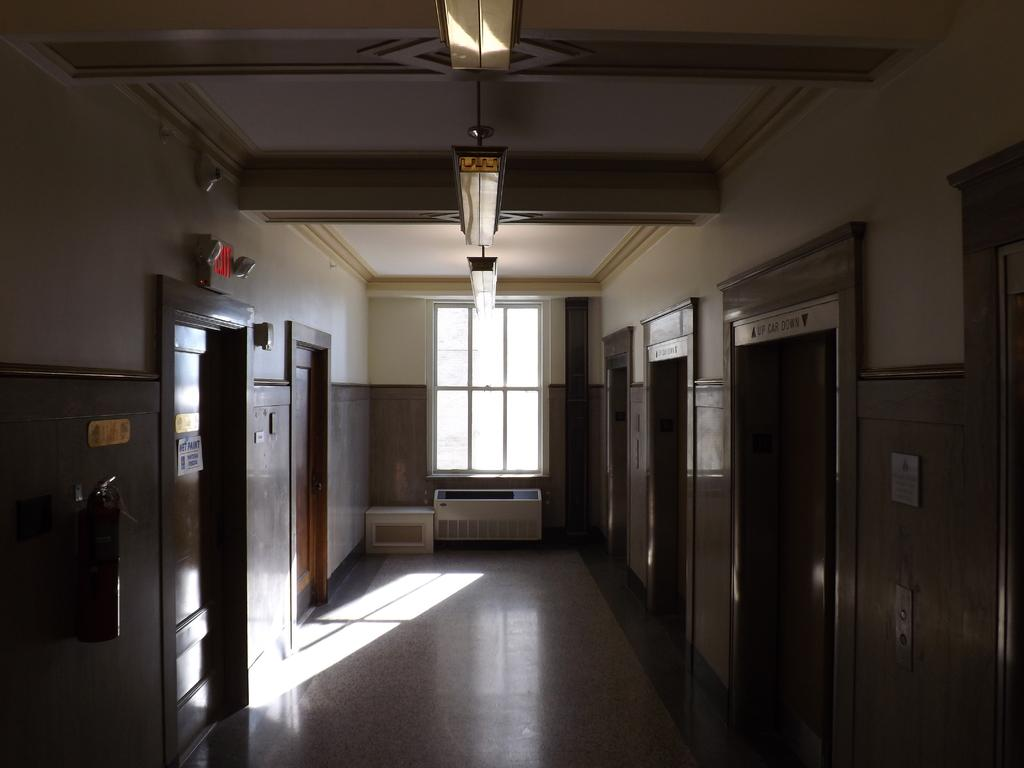What type of openings can be found in the building? There are doors in the building. What type of information is displayed in the building? There are signboards in the building. What type of equipment is present in the building? There are devices in the building. What safety equipment is present in the building? A fire extinguisher is present in the building. What type of surface is used for displaying information in the building? There are boards on a wall in the building. What type of opening allows natural light to enter the building? There is a window in the building. What type of lighting is present on the roof of the building? The building has a roof with ceiling lights. Can you see any branches or berries growing on the walls of the building? No, there are no branches or berries growing on the walls of the building. Is there a lawyer present in the building? The provided facts do not mention the presence of a lawyer in the building. 